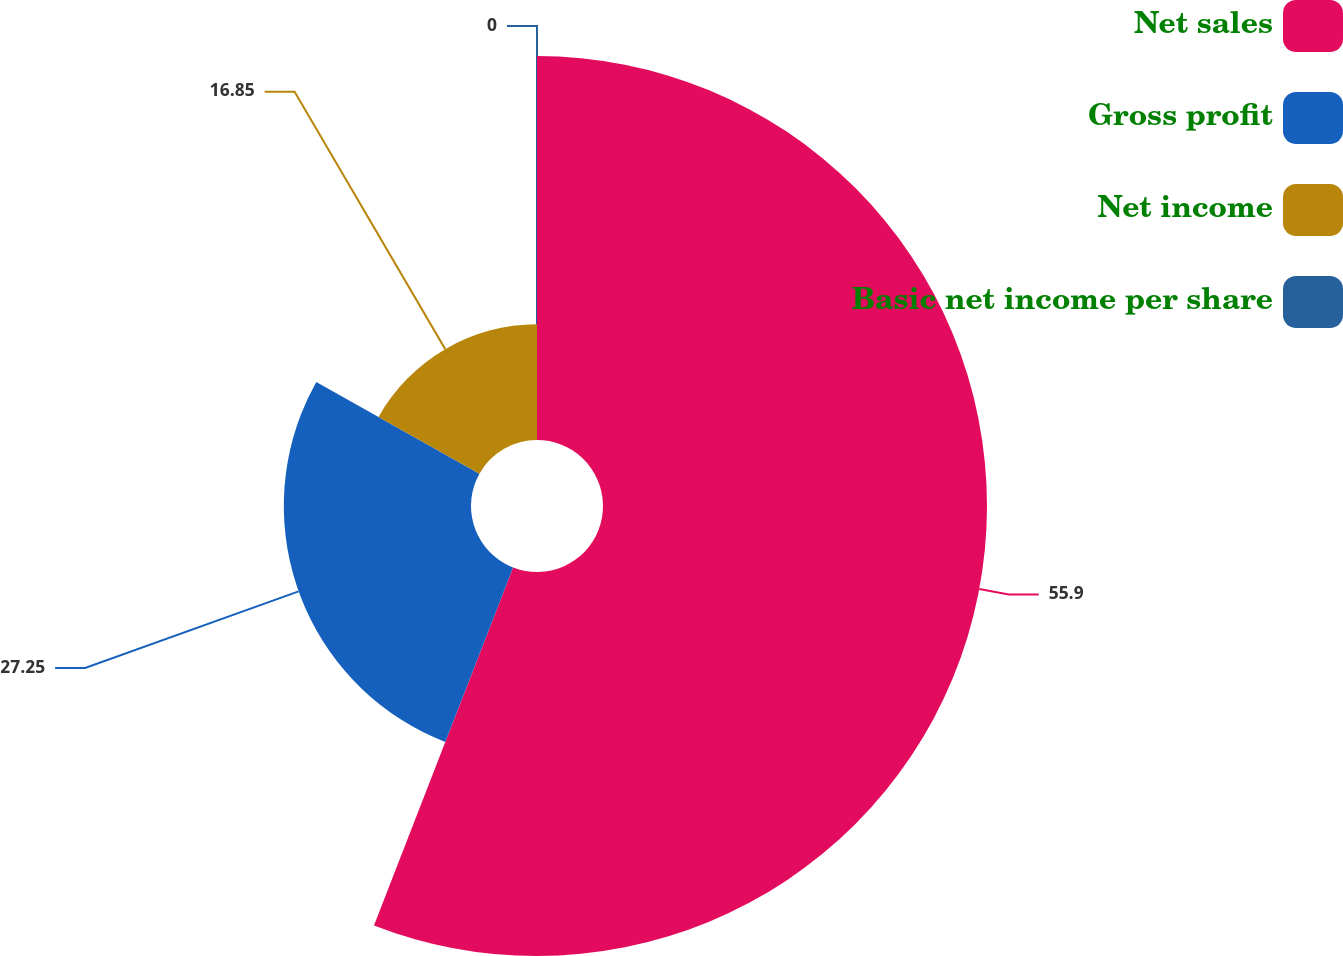Convert chart to OTSL. <chart><loc_0><loc_0><loc_500><loc_500><pie_chart><fcel>Net sales<fcel>Gross profit<fcel>Net income<fcel>Basic net income per share<nl><fcel>55.9%<fcel>27.25%<fcel>16.85%<fcel>0.0%<nl></chart> 